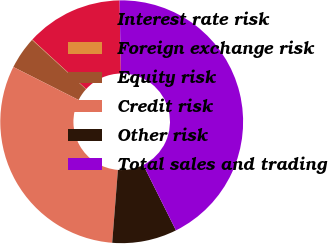Convert chart to OTSL. <chart><loc_0><loc_0><loc_500><loc_500><pie_chart><fcel>Interest rate risk<fcel>Foreign exchange risk<fcel>Equity risk<fcel>Credit risk<fcel>Other risk<fcel>Total sales and trading<nl><fcel>12.9%<fcel>0.05%<fcel>4.33%<fcel>31.2%<fcel>8.62%<fcel>42.9%<nl></chart> 